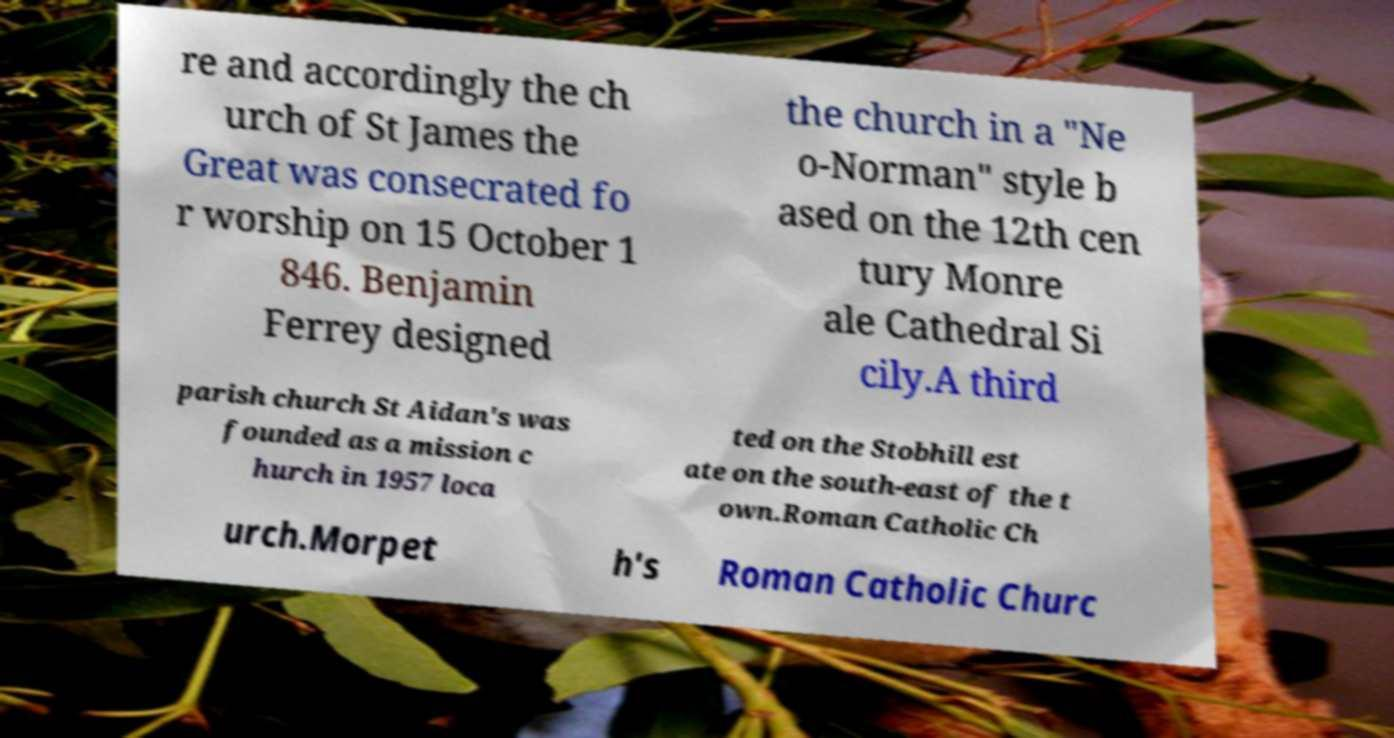Please identify and transcribe the text found in this image. re and accordingly the ch urch of St James the Great was consecrated fo r worship on 15 October 1 846. Benjamin Ferrey designed the church in a "Ne o-Norman" style b ased on the 12th cen tury Monre ale Cathedral Si cily.A third parish church St Aidan's was founded as a mission c hurch in 1957 loca ted on the Stobhill est ate on the south-east of the t own.Roman Catholic Ch urch.Morpet h's Roman Catholic Churc 